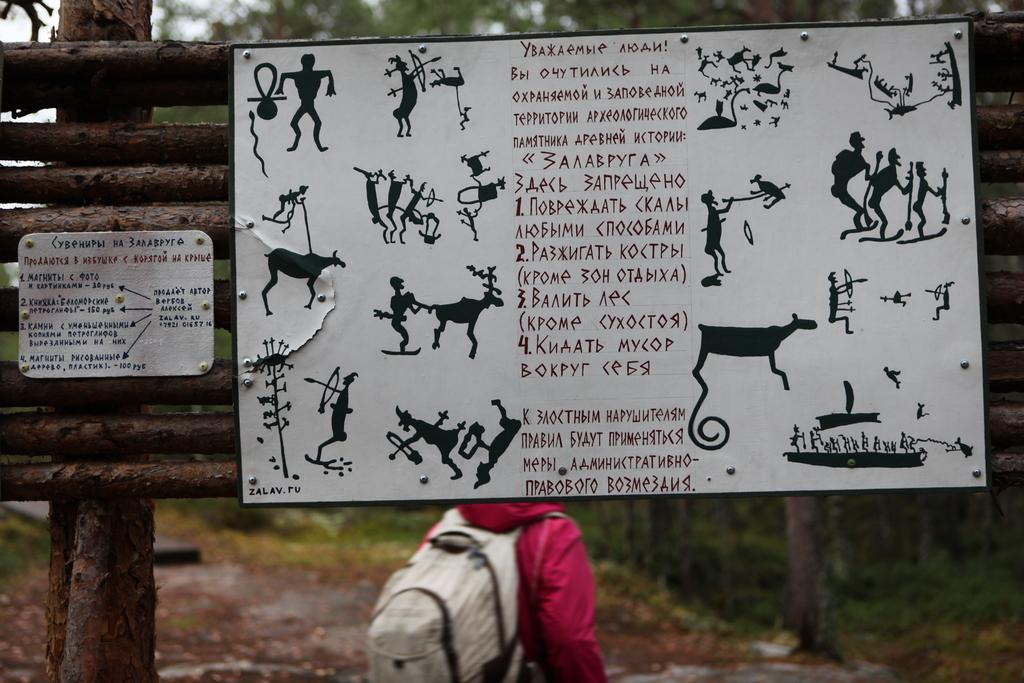What is the color of the poster in the image? The poster in the image is white. Can you describe the person in the image? There is a person standing in the image, and they are carrying a bag. What type of vegetation can be seen in the image? There are green color trees in the image. Where is the man sitting at the table in the image? There is no man or table present in the image; it only features a white color poster, a person standing, and green color trees. 